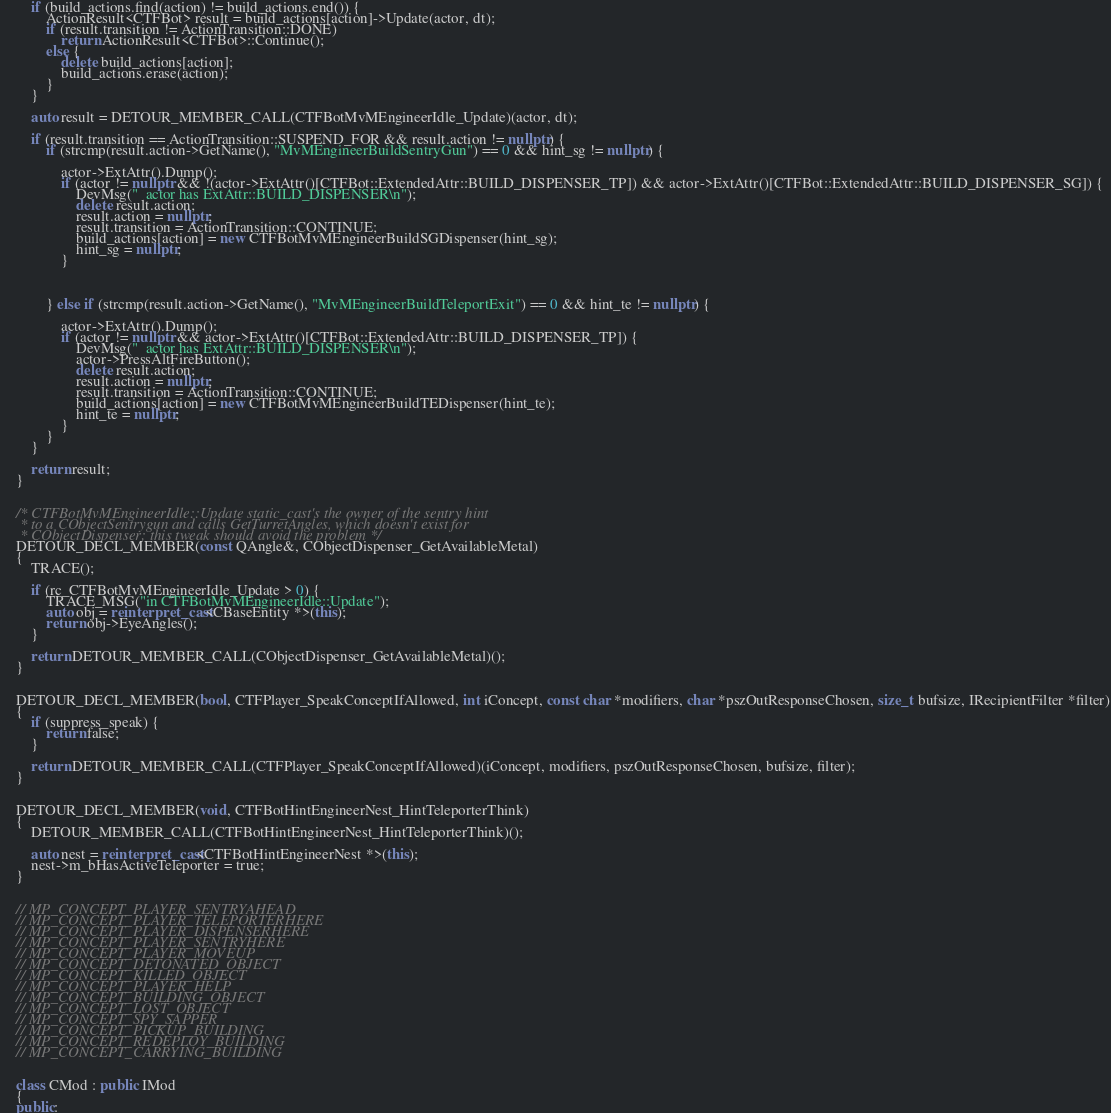<code> <loc_0><loc_0><loc_500><loc_500><_C++_>		if (build_actions.find(action) != build_actions.end()) {
			ActionResult<CTFBot> result = build_actions[action]->Update(actor, dt);
			if (result.transition != ActionTransition::DONE)
				return ActionResult<CTFBot>::Continue();
			else {
				delete build_actions[action];
				build_actions.erase(action);
			}
		}

		auto result = DETOUR_MEMBER_CALL(CTFBotMvMEngineerIdle_Update)(actor, dt);
		
		if (result.transition == ActionTransition::SUSPEND_FOR && result.action != nullptr) {
			if (strcmp(result.action->GetName(), "MvMEngineerBuildSentryGun") == 0 && hint_sg != nullptr) {

				actor->ExtAttr().Dump();
				if (actor != nullptr && !(actor->ExtAttr()[CTFBot::ExtendedAttr::BUILD_DISPENSER_TP]) && actor->ExtAttr()[CTFBot::ExtendedAttr::BUILD_DISPENSER_SG]) {
					DevMsg("  actor has ExtAttr::BUILD_DISPENSER\n");
					delete result.action;
					result.action = nullptr;
					result.transition = ActionTransition::CONTINUE;
					build_actions[action] = new CTFBotMvMEngineerBuildSGDispenser(hint_sg);
					hint_sg = nullptr;
				}

				
				
			} else if (strcmp(result.action->GetName(), "MvMEngineerBuildTeleportExit") == 0 && hint_te != nullptr) {

				actor->ExtAttr().Dump();
				if (actor != nullptr && actor->ExtAttr()[CTFBot::ExtendedAttr::BUILD_DISPENSER_TP]) {
					DevMsg("  actor has ExtAttr::BUILD_DISPENSER\n");
					actor->PressAltFireButton();
					delete result.action;
					result.action = nullptr;
					result.transition = ActionTransition::CONTINUE;
					build_actions[action] = new CTFBotMvMEngineerBuildTEDispenser(hint_te);
					hint_te = nullptr;
				}
			}
		}
		
		return result;
	}
	

	/* CTFBotMvMEngineerIdle::Update static_cast's the owner of the sentry hint
	 * to a CObjectSentrygun and calls GetTurretAngles, which doesn't exist for
	 * CObjectDispenser; this tweak should avoid the problem */
	DETOUR_DECL_MEMBER(const QAngle&, CObjectDispenser_GetAvailableMetal)
	{
		TRACE();
		
		if (rc_CTFBotMvMEngineerIdle_Update > 0) {
			TRACE_MSG("in CTFBotMvMEngineerIdle::Update");
			auto obj = reinterpret_cast<CBaseEntity *>(this);
			return obj->EyeAngles();
		}
		
		return DETOUR_MEMBER_CALL(CObjectDispenser_GetAvailableMetal)();
	}
	
	
	DETOUR_DECL_MEMBER(bool, CTFPlayer_SpeakConceptIfAllowed, int iConcept, const char *modifiers, char *pszOutResponseChosen, size_t bufsize, IRecipientFilter *filter)
	{
		if (suppress_speak) {
			return false;
		}
		
		return DETOUR_MEMBER_CALL(CTFPlayer_SpeakConceptIfAllowed)(iConcept, modifiers, pszOutResponseChosen, bufsize, filter);
	}
	
	
	DETOUR_DECL_MEMBER(void, CTFBotHintEngineerNest_HintTeleporterThink)
	{
		DETOUR_MEMBER_CALL(CTFBotHintEngineerNest_HintTeleporterThink)();
		
		auto nest = reinterpret_cast<CTFBotHintEngineerNest *>(this);
		nest->m_bHasActiveTeleporter = true;
	}
	
	
	// MP_CONCEPT_PLAYER_SENTRYAHEAD
	// MP_CONCEPT_PLAYER_TELEPORTERHERE
	// MP_CONCEPT_PLAYER_DISPENSERHERE
	// MP_CONCEPT_PLAYER_SENTRYHERE
	// MP_CONCEPT_PLAYER_MOVEUP
	// MP_CONCEPT_DETONATED_OBJECT
	// MP_CONCEPT_KILLED_OBJECT
	// MP_CONCEPT_PLAYER_HELP
	// MP_CONCEPT_BUILDING_OBJECT
	// MP_CONCEPT_LOST_OBJECT
	// MP_CONCEPT_SPY_SAPPER
	// MP_CONCEPT_PICKUP_BUILDING
	// MP_CONCEPT_REDEPLOY_BUILDING
	// MP_CONCEPT_CARRYING_BUILDING
	
	
	class CMod : public IMod
	{
	public:</code> 